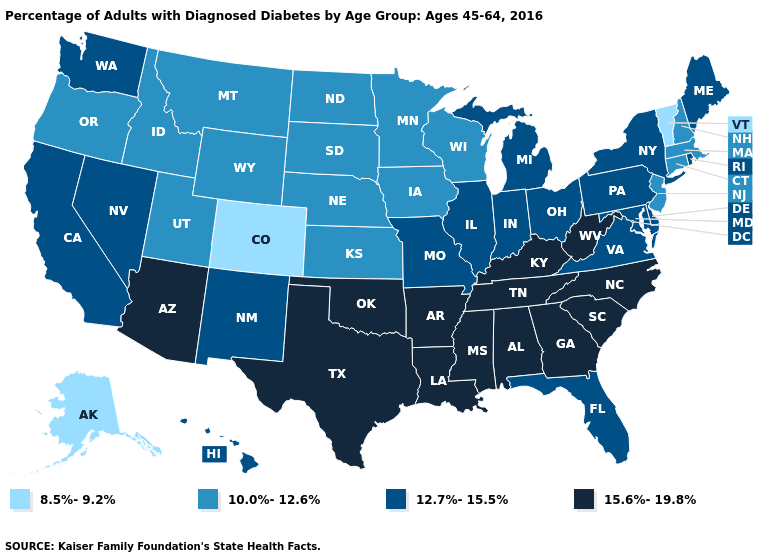What is the value of Delaware?
Short answer required. 12.7%-15.5%. Name the states that have a value in the range 10.0%-12.6%?
Write a very short answer. Connecticut, Idaho, Iowa, Kansas, Massachusetts, Minnesota, Montana, Nebraska, New Hampshire, New Jersey, North Dakota, Oregon, South Dakota, Utah, Wisconsin, Wyoming. Does Idaho have the highest value in the USA?
Be succinct. No. Does Michigan have the same value as California?
Be succinct. Yes. Does Mississippi have the same value as Idaho?
Answer briefly. No. Among the states that border Utah , does Colorado have the highest value?
Quick response, please. No. What is the value of New Jersey?
Be succinct. 10.0%-12.6%. Which states hav the highest value in the Northeast?
Concise answer only. Maine, New York, Pennsylvania, Rhode Island. Which states have the lowest value in the MidWest?
Short answer required. Iowa, Kansas, Minnesota, Nebraska, North Dakota, South Dakota, Wisconsin. What is the value of Montana?
Answer briefly. 10.0%-12.6%. What is the highest value in states that border Georgia?
Write a very short answer. 15.6%-19.8%. Which states hav the highest value in the Northeast?
Answer briefly. Maine, New York, Pennsylvania, Rhode Island. Does Arizona have the same value as Arkansas?
Short answer required. Yes. Which states have the lowest value in the USA?
Give a very brief answer. Alaska, Colorado, Vermont. Name the states that have a value in the range 8.5%-9.2%?
Be succinct. Alaska, Colorado, Vermont. 